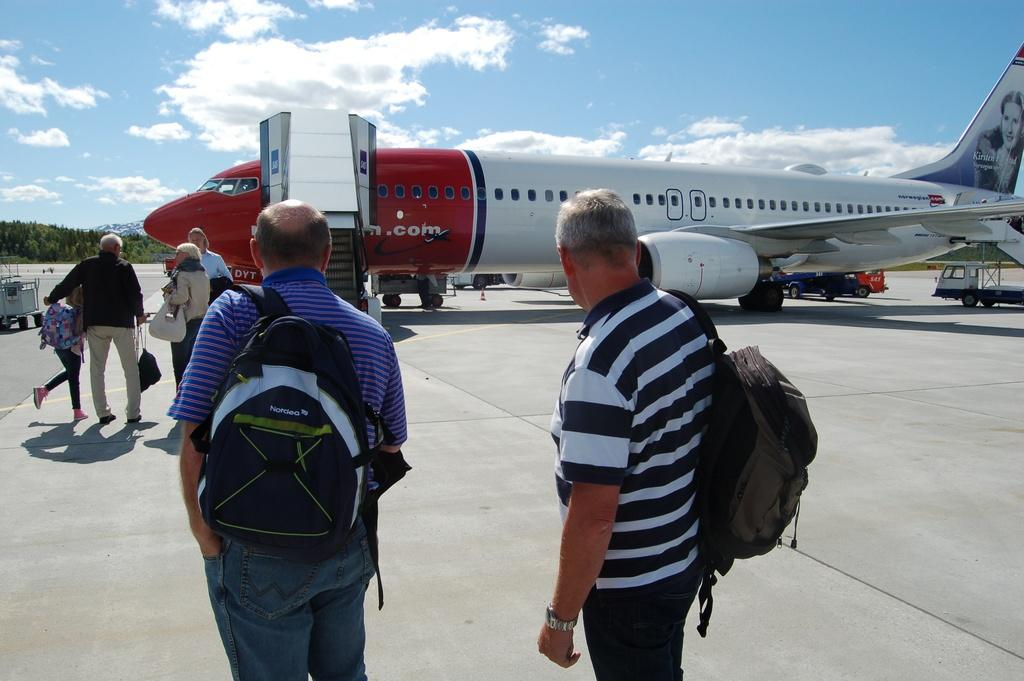Provide a one-sentence caption for the provided image. people getting ready to board a red and white norwegian airplane. 